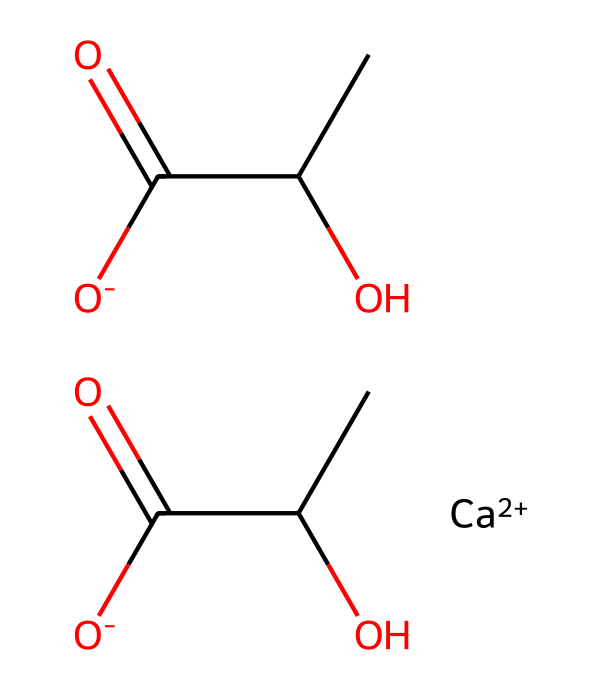What is the total number of carbon atoms in calcium lactate? The SMILES representation indicates two separate building blocks of lactate, each containing three carbon atoms (from CC(O)C(=O)[O-]). Since there are two lactate units, we multiply three by two for a total of six carbon atoms.
Answer: six How many oxygen atoms are present in this structure? Analyzing the structure, there are three oxygen atoms from each lactate group and one extra oxygen due to the calcium ion (counting the carboxylic groups). Therefore, 3 (from one lactate) + 3 (from the second lactate) + 1 (the free oxygen from the calcium) totals seven oxygen atoms.
Answer: seven What type of chemical is calcium lactate classified as? Calcium lactate consists of calcium ions and lactate ions, which makes it a mineral supplement that serves as an electrolyte. Thus, it falls under the category of salts.
Answer: salt Does this molecule contain any chiral centers? Observing the structure, there are two stereogenic centers in the lactate moieties, located at each chiral carbon (the one with the hydroxyl group). Each of these carbons can be classified as chiral due to the presence of four distinct substituents attached.
Answer: yes What role does calcium play in the body based on this chemical structure? Calcium, as found in calcium lactate, is essential for various physiological functions, especially in muscle contractions and nerve signaling, where it acts as an electrolyte. This makes it critical in the regulation of cardiovascular and muscle functions.
Answer: signaling How many lactate molecules contribute to one calcium lactate unit? By interpreting the SMILES representation, each unit of calcium lactate comprises two lactate molecules bonded to a calcium ion, showing a 1:2 ratio.
Answer: two 